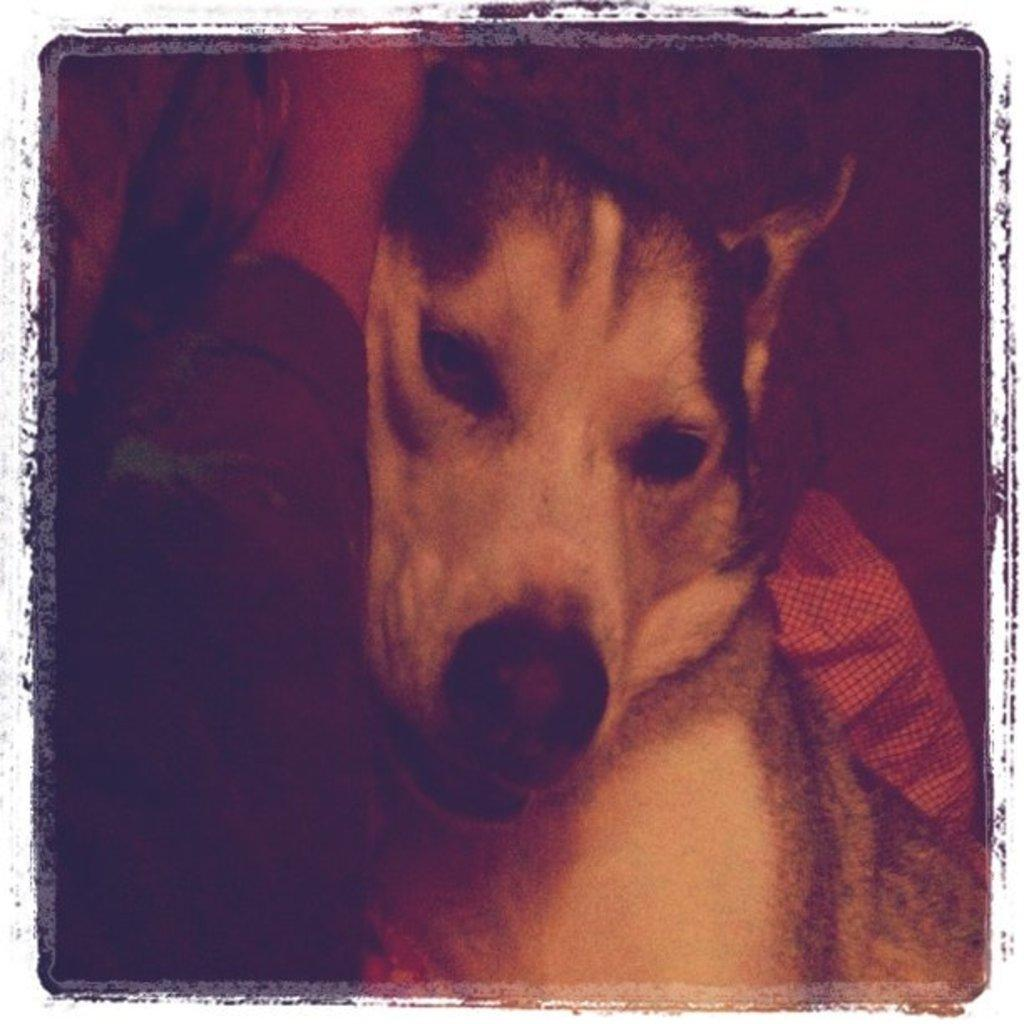What type of animal is present in the image? There is a dog in the image. Can you describe the lighting conditions in the image? The image is dark. What type of slave is depicted in the image? There is no slave depicted in the image; it features a dog. What type of brass object can be seen in the image? There is no brass object present in the image. 